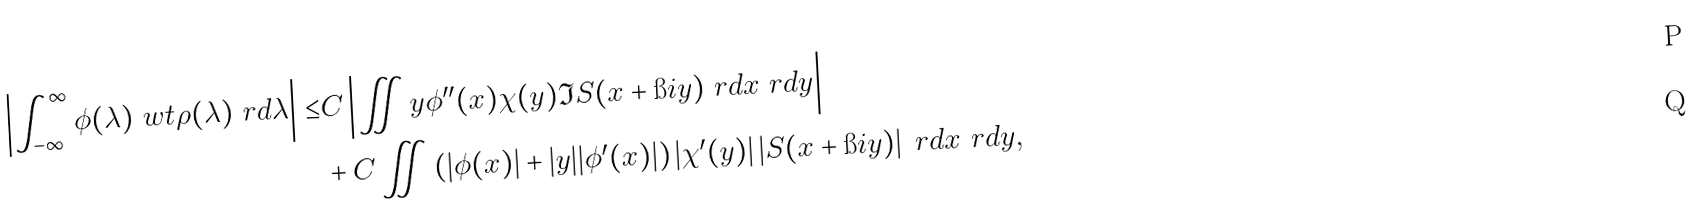<formula> <loc_0><loc_0><loc_500><loc_500>\left | \int _ { - \infty } ^ { \infty } \phi ( \lambda ) \ w t \rho ( \lambda ) \ r d \lambda \right | \leq & C \left | \iint y \phi ^ { \prime \prime } ( x ) \chi ( y ) \Im S ( x + \i i y ) \ r d x \ r d y \right | \\ & + C \iint \left ( | \phi ( x ) | + | y | | \phi ^ { \prime } ( x ) | \right ) | \chi ^ { \prime } ( y ) | \left | S ( x + \i i y ) \right | \ r d x \ r d y ,</formula> 